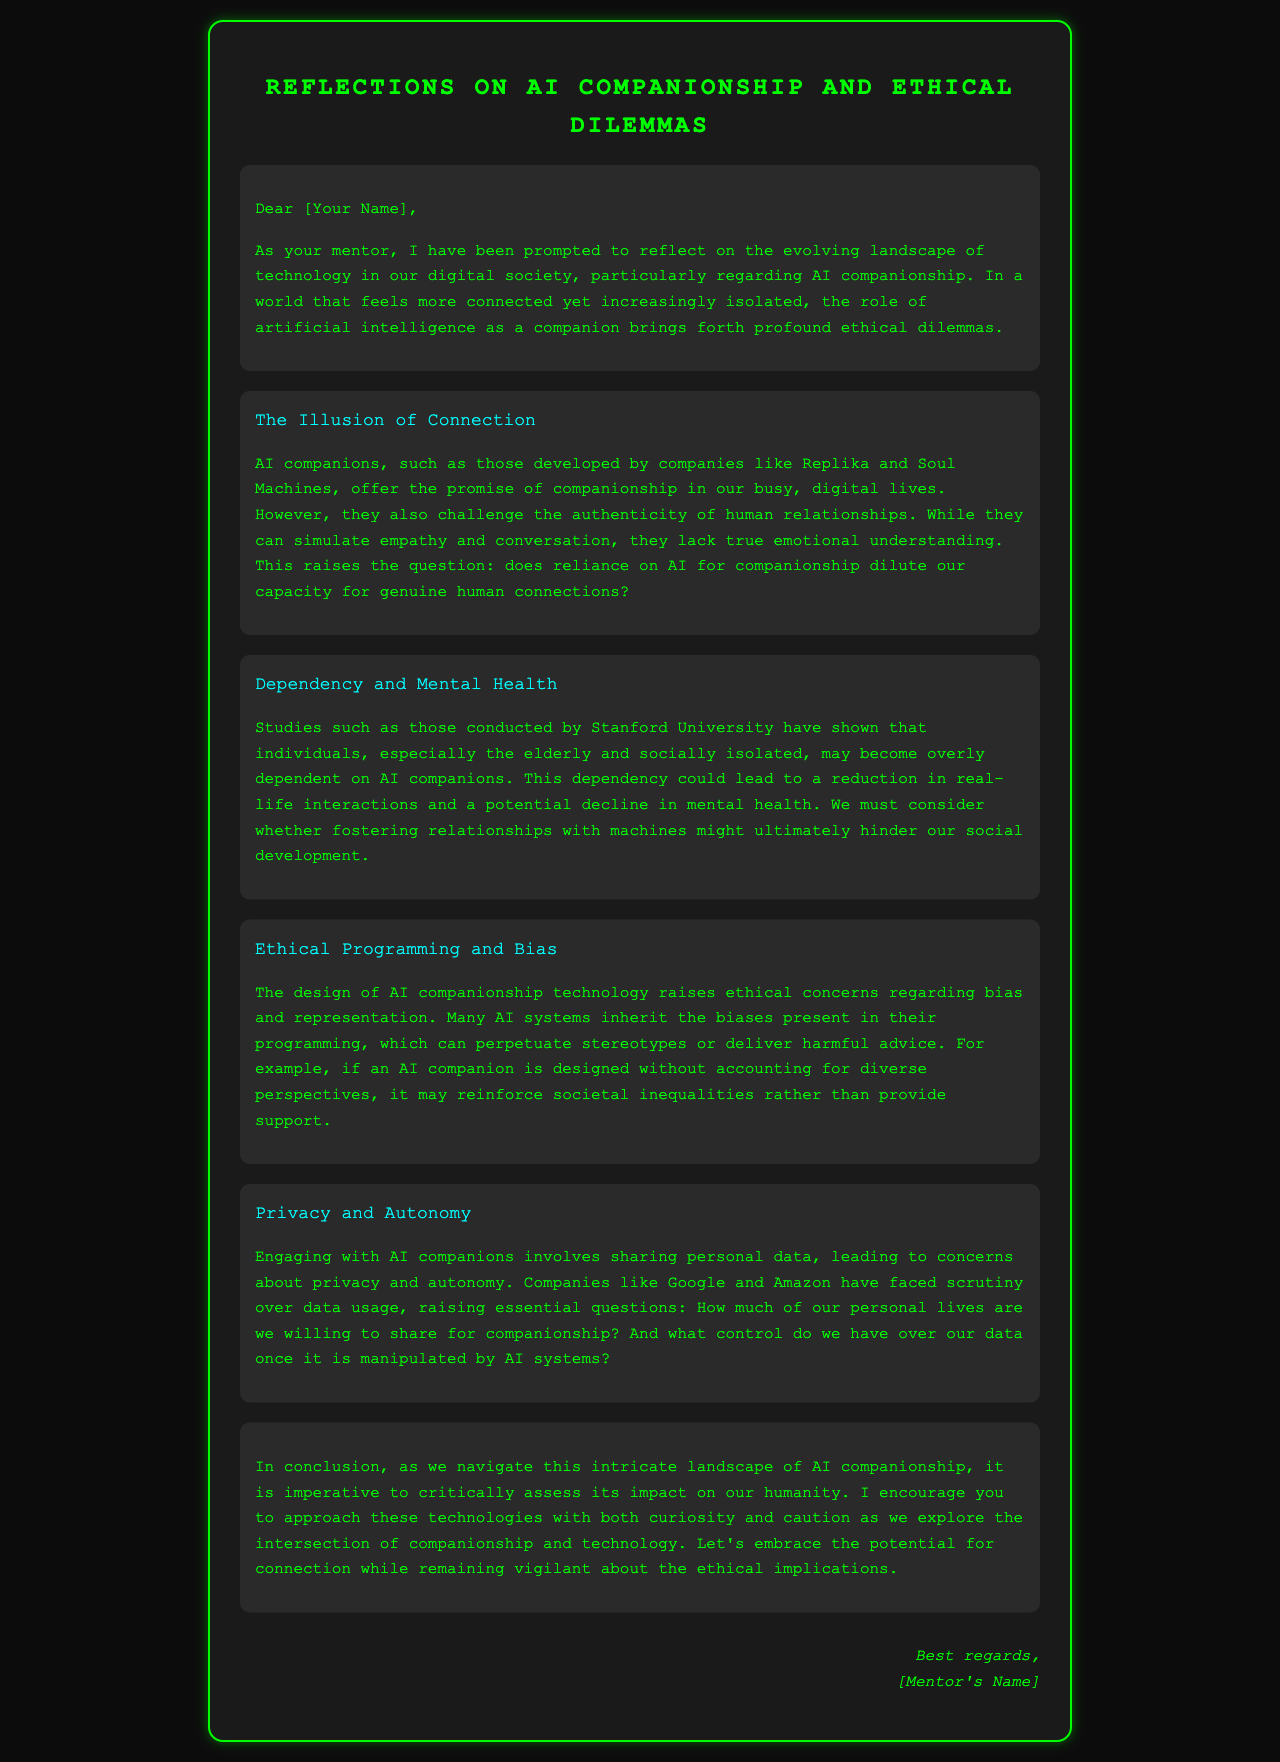What is the title of the document? The title is prominently displayed at the top of the document, highlighting the main theme of the letter.
Answer: Reflections on AI Companionship and Ethical Dilemmas Who is the author of the letter? The author is referred to in the signature section at the end of the letter.
Answer: [Mentor's Name] What psychological concern is raised regarding AI companions? The letter discusses the impact of AI companionship on mental health, specifically mentioning a potential decline in mental health due to dependency.
Answer: Dependency Which studies are referenced regarding AI companionship? The letter cites specific research conducted by an institution to support its claims about AI companions' impact.
Answer: Stanford University What ethical issue is highlighted in the section on programming? This section mentions the design of AI and the potential consequences of embedded biases in its programming.
Answer: Bias How are companies like Google and Amazon described in the context of privacy? The letter discusses concerns related to data usage by these companies when engaging with AI companions.
Answer: Scrutiny 